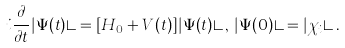Convert formula to latex. <formula><loc_0><loc_0><loc_500><loc_500>i \frac { \partial } { \partial t } | \Psi ( t ) \rangle = [ H _ { 0 } + V ( t ) ] | \Psi ( t ) \rangle \, , \, | \Psi ( 0 ) \rangle = | \chi _ { i } \rangle \, .</formula> 